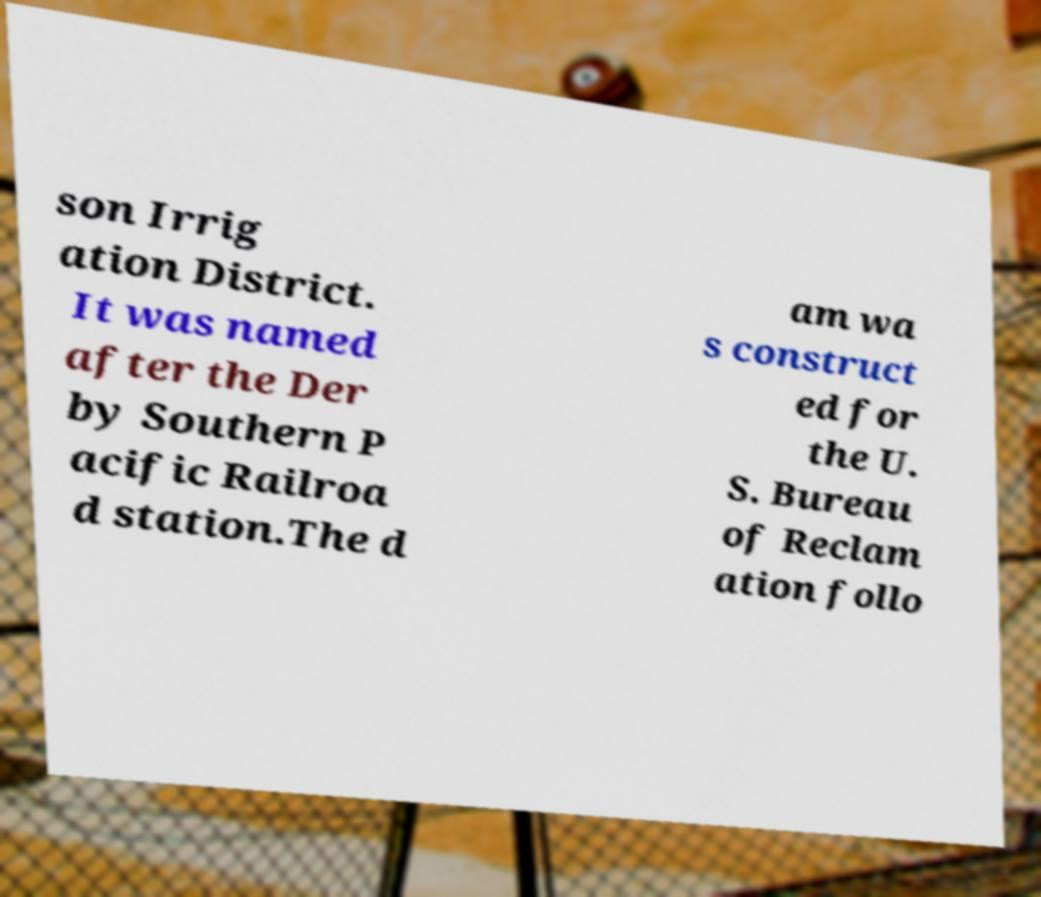Could you assist in decoding the text presented in this image and type it out clearly? son Irrig ation District. It was named after the Der by Southern P acific Railroa d station.The d am wa s construct ed for the U. S. Bureau of Reclam ation follo 